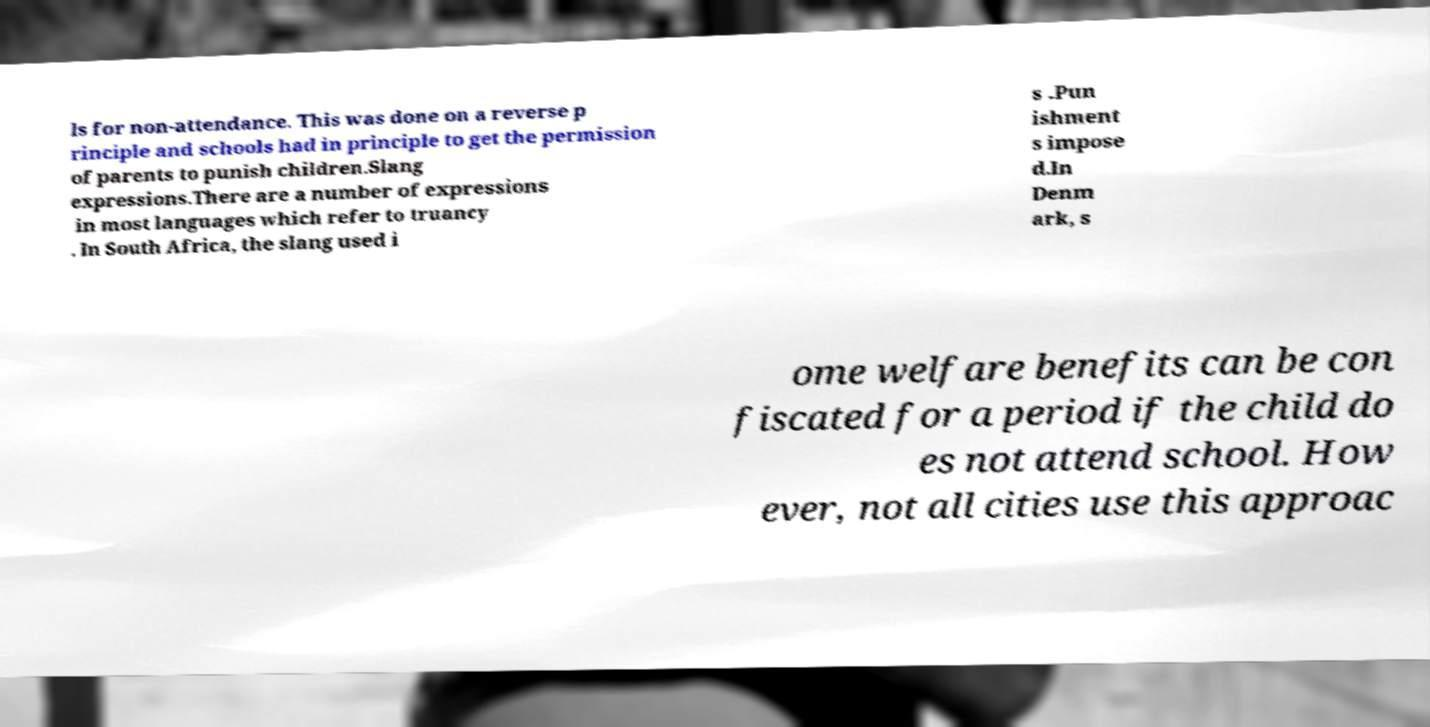Please read and relay the text visible in this image. What does it say? ls for non-attendance. This was done on a reverse p rinciple and schools had in principle to get the permission of parents to punish children.Slang expressions.There are a number of expressions in most languages which refer to truancy . In South Africa, the slang used i s .Pun ishment s impose d.In Denm ark, s ome welfare benefits can be con fiscated for a period if the child do es not attend school. How ever, not all cities use this approac 